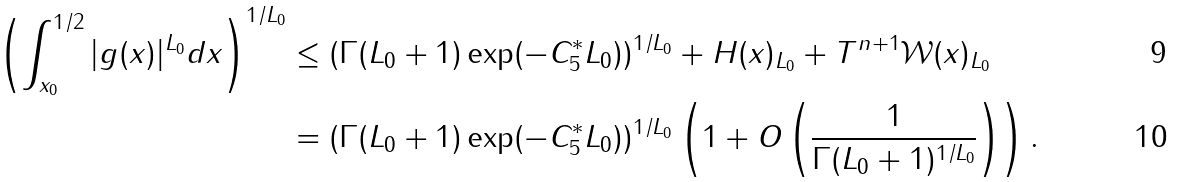<formula> <loc_0><loc_0><loc_500><loc_500>\left ( \int _ { x _ { 0 } } ^ { 1 / 2 } | g ( x ) | ^ { L _ { 0 } } d x \right ) ^ { 1 / L _ { 0 } } & \leq ( \Gamma ( L _ { 0 } + 1 ) \exp ( - C _ { 5 } ^ { * } L _ { 0 } ) ) ^ { 1 / L _ { 0 } } + \| H ( x ) \| _ { L _ { 0 } } + \| T ^ { n + 1 } \mathcal { W } ( x ) \| _ { L _ { 0 } } \\ & = ( \Gamma ( L _ { 0 } + 1 ) \exp ( - C _ { 5 } ^ { * } L _ { 0 } ) ) ^ { 1 / L _ { 0 } } \left ( 1 + O \left ( \frac { 1 } { \Gamma ( L _ { 0 } + 1 ) ^ { 1 / L _ { 0 } } } \right ) \right ) .</formula> 